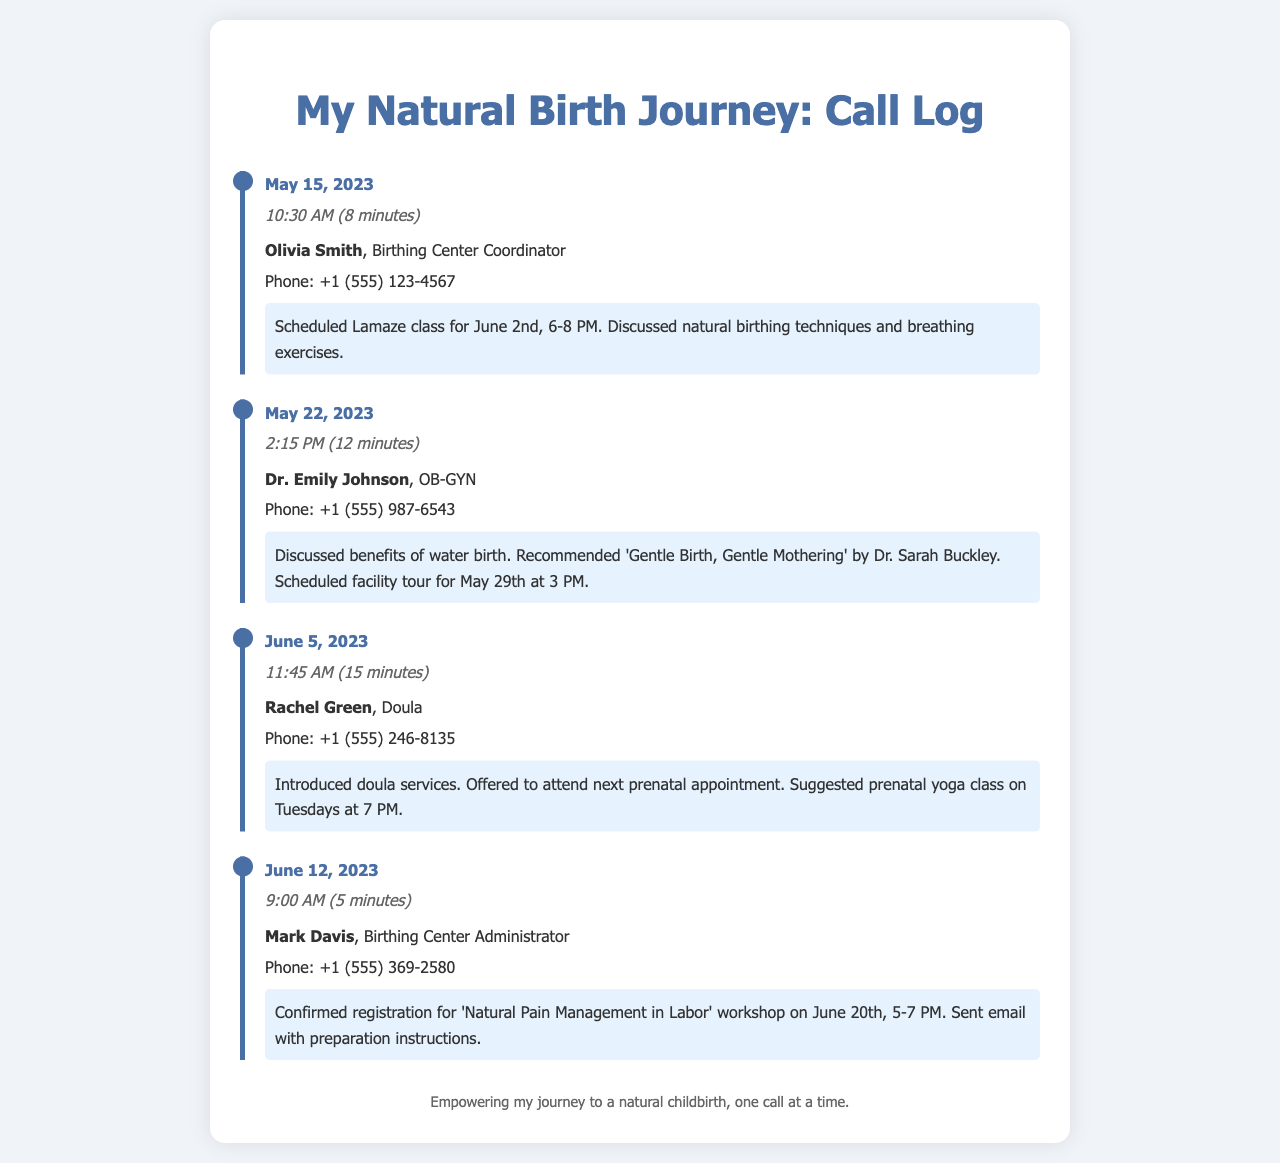What is the name of the birthing center coordinator? The call log states that the coordinator's name is Olivia Smith.
Answer: Olivia Smith When is the scheduled Lamaze class? The call log mentions the Lamaze class is scheduled for June 2nd from 6-8 PM.
Answer: June 2nd, 6-8 PM Who recommended a book during the call? Dr. Emily Johnson recommended the book 'Gentle Birth, Gentle Mothering' by Dr. Sarah Buckley.
Answer: Dr. Emily Johnson What is the date and time for the facility tour? The facility tour was scheduled for May 29th at 3 PM according to the call log.
Answer: May 29th, 3 PM How long did the call with Mark Davis last? The call log indicates that the call with Mark Davis lasted for 5 minutes.
Answer: 5 minutes What workshop did Mark Davis confirm registration for? The call log specifies the workshop as 'Natural Pain Management in Labor' on June 20th.
Answer: Natural Pain Management in Labor What is suggested for prenatal yoga? Rachel Green suggested a prenatal yoga class on Tuesdays at 7 PM.
Answer: Tuesdays at 7 PM How many minutes did Rachel Green's call last? The document states that Rachel Green's call lasted for 15 minutes.
Answer: 15 minutes What was the main topic of the call with Dr. Emily Johnson? The main topic discussed during the call with Dr. Emily Johnson was the benefits of water birth.
Answer: Benefits of water birth 